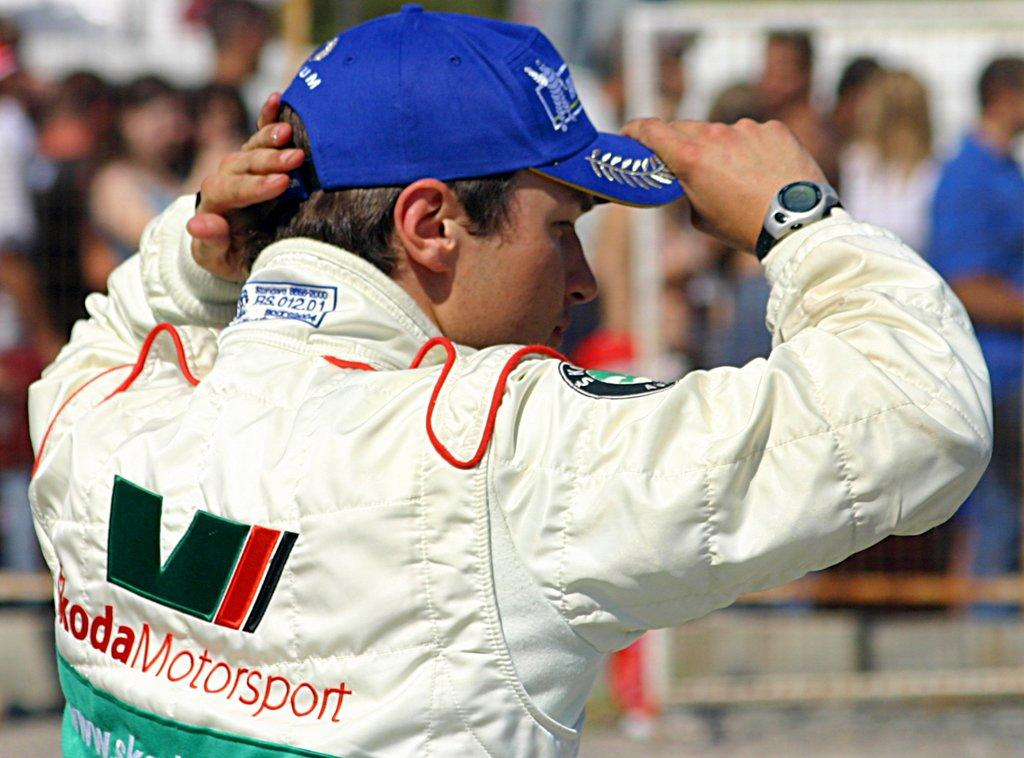<image>
Offer a succinct explanation of the picture presented. A person wearing a white motorsport jacket and a blue hat stands outside. 